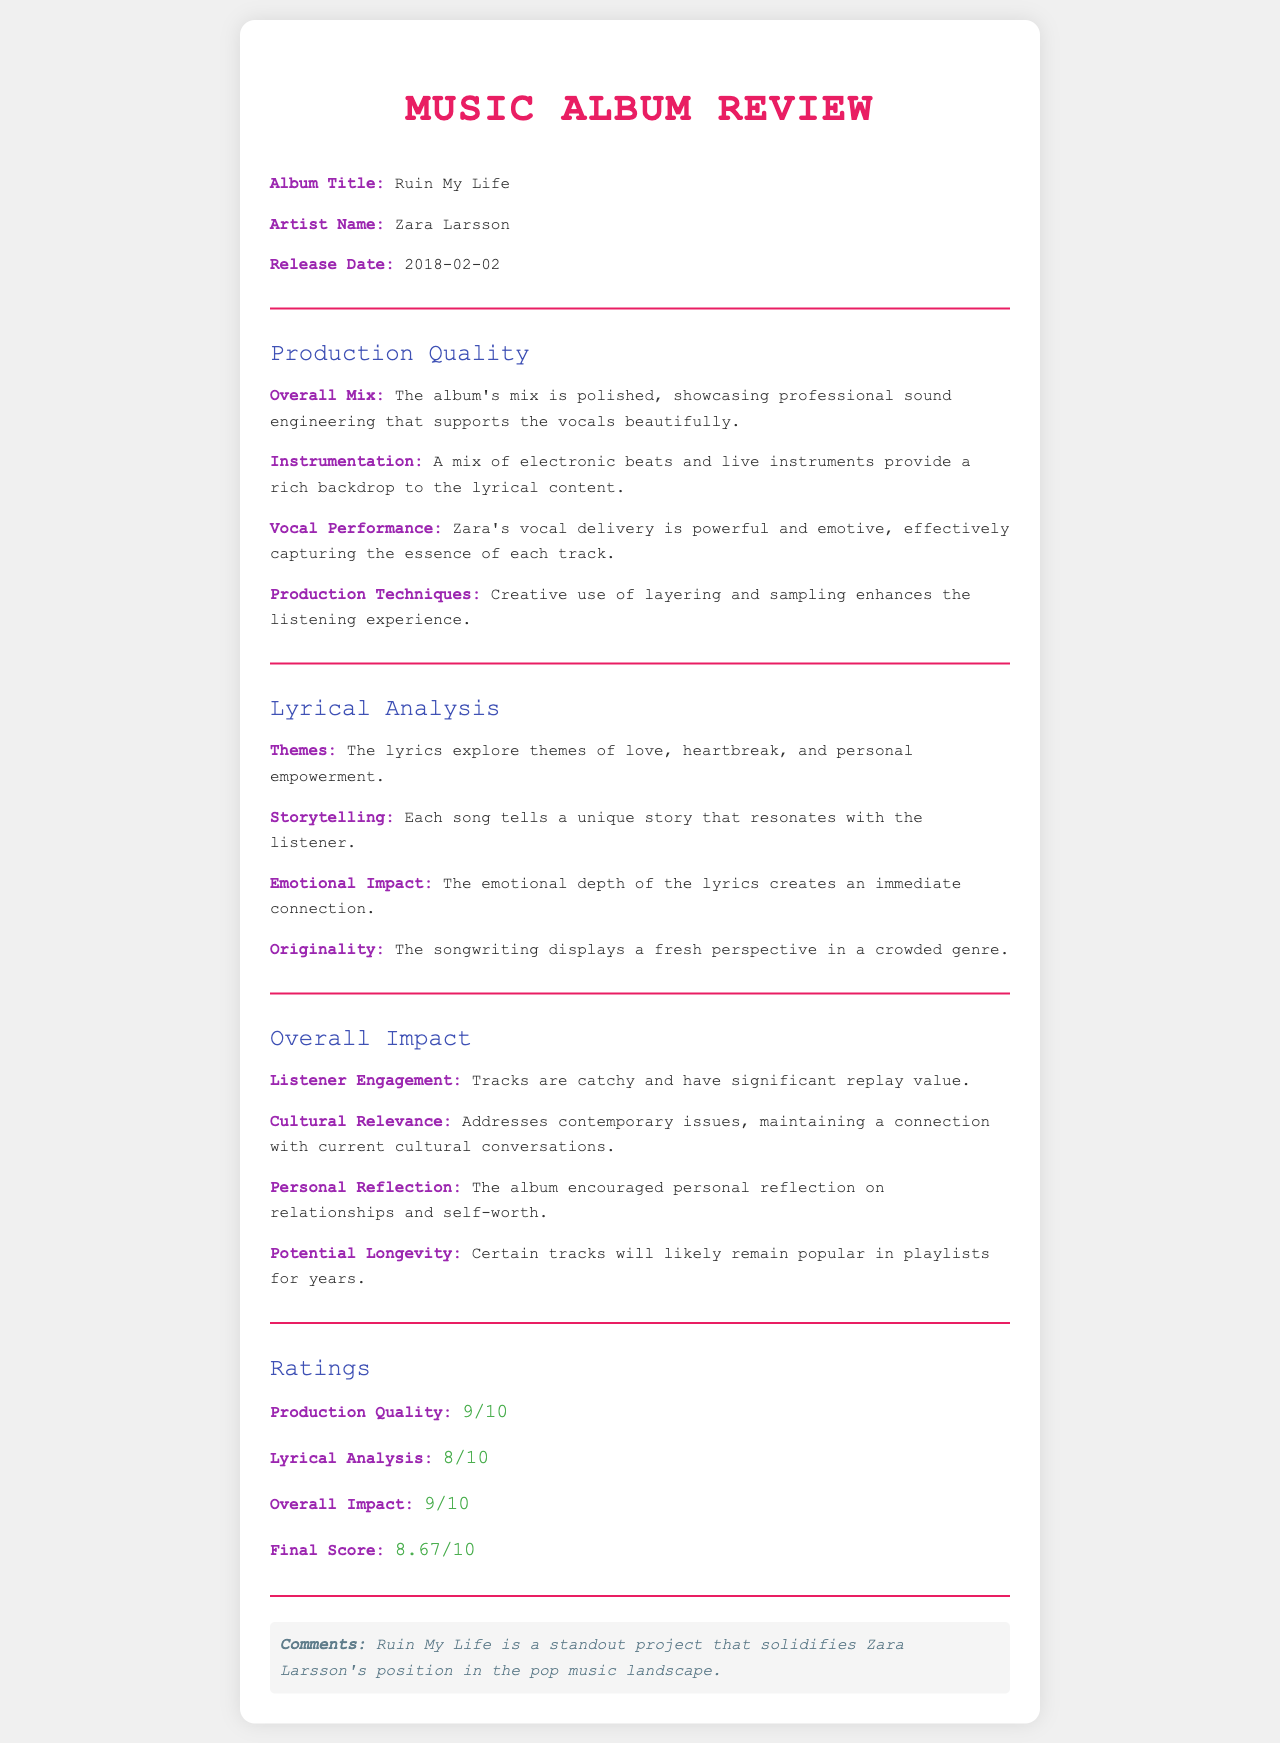What is the title of the album? The title of the album is explicitly stated under the Album Title section of the document.
Answer: Ruin My Life Who is the artist of the album? The artist's name is mentioned directly in the document under the Artist Name section.
Answer: Zara Larsson When was the album released? The release date is provided in the document under the Release Date section.
Answer: 2018-02-02 What rating was given for Production Quality? The Production Quality rating is found in the Ratings section, representing the assessment of this specific aspect.
Answer: 9/10 What themes do the lyrics explore? The themes of the lyrics are described in the Lyrical Analysis section, summarizing the essence of the lyrical content.
Answer: Love, heartbreak, and personal empowerment How does the album encourage personal reflection? The Overall Impact section discusses how the album prompts listeners to think about relationships and self-worth.
Answer: It encouraged personal reflection on relationships and self-worth What is the final score of the album? The final score is provided in the Ratings section, reflecting the aggregate assessment of the album.
Answer: 8.67/10 Which production technique enhances the listening experience? The Production Techniques field mentions specific methods that elevate the quality of the album.
Answer: Creative use of layering and sampling What is highlighted about Zara's vocal performance? The Vocal Performance field emphasizes a particular quality of Zara's singing that impacts the listener.
Answer: Powerful and emotive What aspect maintains a connection with current cultural conversations? The Cultural Relevance field addresses how the album remains pertinent to contemporary themes.
Answer: It addresses contemporary issues 